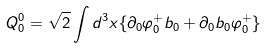<formula> <loc_0><loc_0><loc_500><loc_500>Q ^ { 0 } _ { 0 } = \sqrt { 2 } \int d ^ { 3 } x \{ \partial _ { 0 } \varphi ^ { + } _ { 0 } b _ { 0 } + \partial _ { 0 } b _ { 0 } \varphi ^ { + } _ { 0 } \}</formula> 